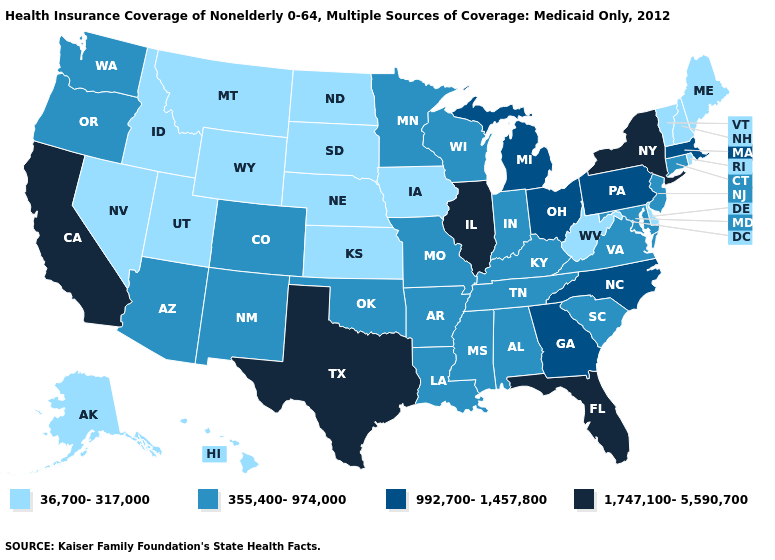Does Alaska have the same value as Vermont?
Give a very brief answer. Yes. Which states have the lowest value in the West?
Short answer required. Alaska, Hawaii, Idaho, Montana, Nevada, Utah, Wyoming. Does Tennessee have a higher value than Arizona?
Short answer required. No. Does New York have a higher value than Maine?
Write a very short answer. Yes. What is the highest value in states that border Texas?
Concise answer only. 355,400-974,000. Does the first symbol in the legend represent the smallest category?
Keep it brief. Yes. Name the states that have a value in the range 36,700-317,000?
Answer briefly. Alaska, Delaware, Hawaii, Idaho, Iowa, Kansas, Maine, Montana, Nebraska, Nevada, New Hampshire, North Dakota, Rhode Island, South Dakota, Utah, Vermont, West Virginia, Wyoming. Does Idaho have a lower value than Arizona?
Give a very brief answer. Yes. Name the states that have a value in the range 992,700-1,457,800?
Give a very brief answer. Georgia, Massachusetts, Michigan, North Carolina, Ohio, Pennsylvania. What is the lowest value in states that border Massachusetts?
Answer briefly. 36,700-317,000. What is the value of Idaho?
Give a very brief answer. 36,700-317,000. Name the states that have a value in the range 1,747,100-5,590,700?
Be succinct. California, Florida, Illinois, New York, Texas. Name the states that have a value in the range 992,700-1,457,800?
Be succinct. Georgia, Massachusetts, Michigan, North Carolina, Ohio, Pennsylvania. Does the first symbol in the legend represent the smallest category?
Write a very short answer. Yes. What is the value of Utah?
Answer briefly. 36,700-317,000. 